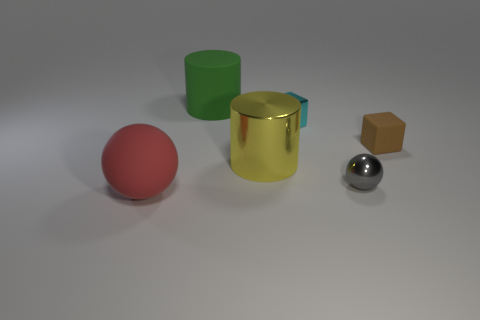Can you describe the textures visible in this image? Certainly! The red rubber sphere has a matte finish suggesting a slightly rough texture typical of rubber objects. In contrast, the gold-colored cylinder and the silver sphere exhibit smooth, polished metallic textures with specular highlights reflecting the light source. The green cylinder has a less reflective, matte finish that could be indicative of a plastic material. Lastly, the tiny brown box has a visibly grainier texture, possibly indicative of cardboard or a coarse wood. 